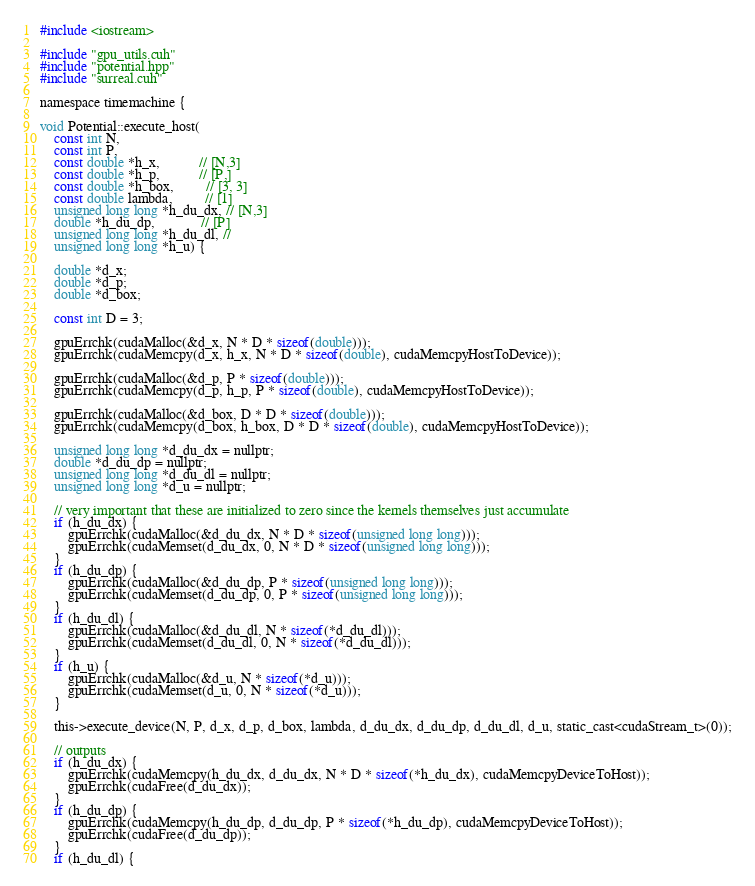<code> <loc_0><loc_0><loc_500><loc_500><_Cuda_>#include <iostream>

#include "gpu_utils.cuh"
#include "potential.hpp"
#include "surreal.cuh"

namespace timemachine {

void Potential::execute_host(
    const int N,
    const int P,
    const double *h_x,           // [N,3]
    const double *h_p,           // [P,]
    const double *h_box,         // [3, 3]
    const double lambda,         // [1]
    unsigned long long *h_du_dx, // [N,3]
    double *h_du_dp,             // [P]
    unsigned long long *h_du_dl, //
    unsigned long long *h_u) {

    double *d_x;
    double *d_p;
    double *d_box;

    const int D = 3;

    gpuErrchk(cudaMalloc(&d_x, N * D * sizeof(double)));
    gpuErrchk(cudaMemcpy(d_x, h_x, N * D * sizeof(double), cudaMemcpyHostToDevice));

    gpuErrchk(cudaMalloc(&d_p, P * sizeof(double)));
    gpuErrchk(cudaMemcpy(d_p, h_p, P * sizeof(double), cudaMemcpyHostToDevice));

    gpuErrchk(cudaMalloc(&d_box, D * D * sizeof(double)));
    gpuErrchk(cudaMemcpy(d_box, h_box, D * D * sizeof(double), cudaMemcpyHostToDevice));

    unsigned long long *d_du_dx = nullptr;
    double *d_du_dp = nullptr;
    unsigned long long *d_du_dl = nullptr;
    unsigned long long *d_u = nullptr;

    // very important that these are initialized to zero since the kernels themselves just accumulate
    if (h_du_dx) {
        gpuErrchk(cudaMalloc(&d_du_dx, N * D * sizeof(unsigned long long)));
        gpuErrchk(cudaMemset(d_du_dx, 0, N * D * sizeof(unsigned long long)));
    }
    if (h_du_dp) {
        gpuErrchk(cudaMalloc(&d_du_dp, P * sizeof(unsigned long long)));
        gpuErrchk(cudaMemset(d_du_dp, 0, P * sizeof(unsigned long long)));
    }
    if (h_du_dl) {
        gpuErrchk(cudaMalloc(&d_du_dl, N * sizeof(*d_du_dl)));
        gpuErrchk(cudaMemset(d_du_dl, 0, N * sizeof(*d_du_dl)));
    }
    if (h_u) {
        gpuErrchk(cudaMalloc(&d_u, N * sizeof(*d_u)));
        gpuErrchk(cudaMemset(d_u, 0, N * sizeof(*d_u)));
    }

    this->execute_device(N, P, d_x, d_p, d_box, lambda, d_du_dx, d_du_dp, d_du_dl, d_u, static_cast<cudaStream_t>(0));

    // outputs
    if (h_du_dx) {
        gpuErrchk(cudaMemcpy(h_du_dx, d_du_dx, N * D * sizeof(*h_du_dx), cudaMemcpyDeviceToHost));
        gpuErrchk(cudaFree(d_du_dx));
    }
    if (h_du_dp) {
        gpuErrchk(cudaMemcpy(h_du_dp, d_du_dp, P * sizeof(*h_du_dp), cudaMemcpyDeviceToHost));
        gpuErrchk(cudaFree(d_du_dp));
    }
    if (h_du_dl) {</code> 